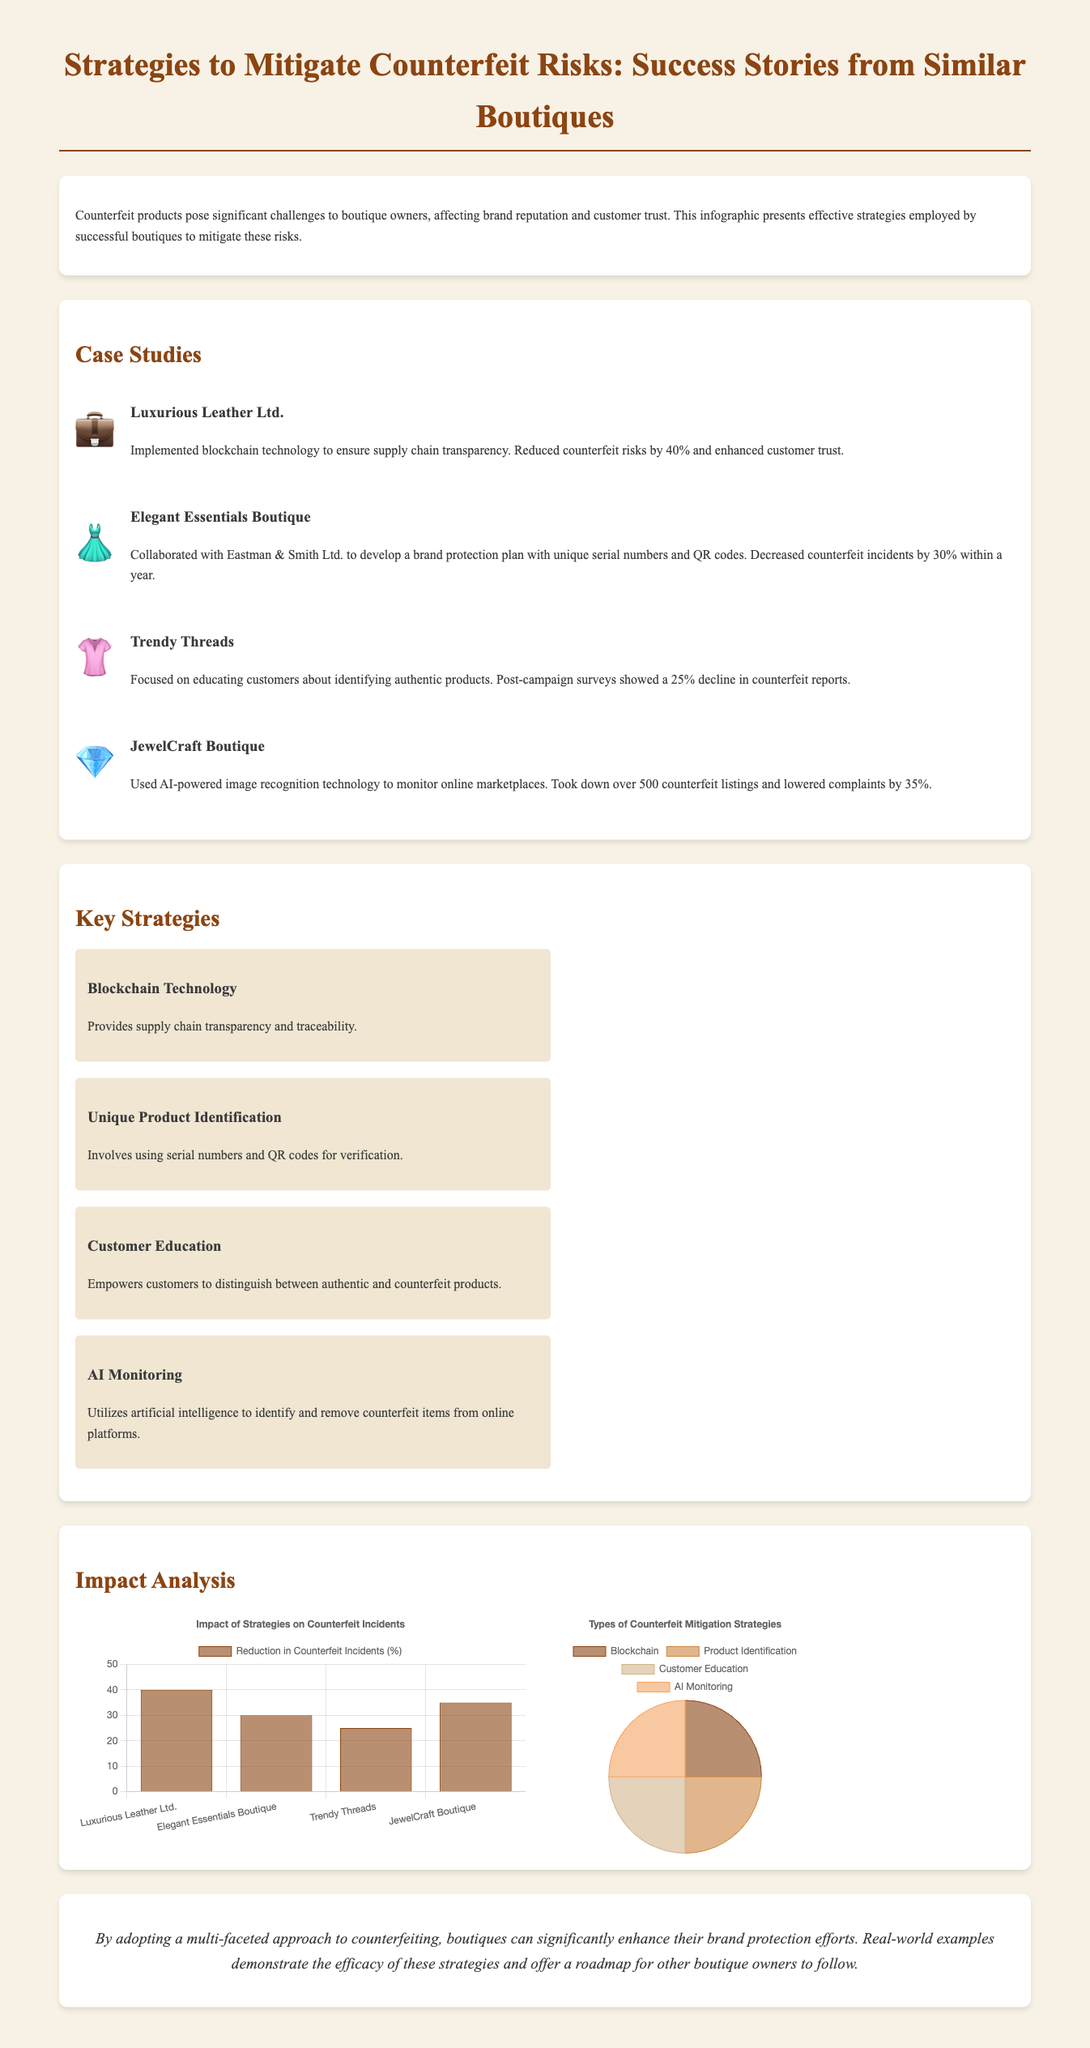What was the reduction in counterfeit incidents for Luxurious Leather Ltd.? The document states that Luxurious Leather Ltd. reduced counterfeit risks by 40%.
Answer: 40% Which technology did JewelCraft Boutique use to monitor online marketplaces? The document mentions that JewelCraft Boutique used AI-powered image recognition technology.
Answer: AI-powered image recognition What percentage decline in counterfeit reports did Trendy Threads experience? The document indicates that Trendy Threads saw a 25% decline in counterfeit reports post-campaign.
Answer: 25% Which boutique collaborated with Eastman & Smith Ltd.? The document identifies Elegant Essentials Boutique as the one that collaborated with Eastman & Smith Ltd.
Answer: Elegant Essentials Boutique What type of chart is used to show the impact of strategies on counterfeit incidents? The document specifies that a bar chart is used for this purpose.
Answer: Bar chart How many total types of counterfeit mitigation strategies are presented? The document lists four types of strategies used to mitigate counterfeiting risks.
Answer: Four Which strategy is associated with providing supply chain transparency? The document mentions that Blockchain Technology is related to supply chain transparency.
Answer: Blockchain Technology What visual element is used to represent the types of strategies in a pie chart? The document states that the pie chart shows the proportions of different counterfeit mitigation strategies.
Answer: Proportions What is the main purpose of the infographic? The overarching goal of the infographic is to present effective strategies employed by successful boutiques to mitigate counterfeit risks.
Answer: Mitigate counterfeit risks 